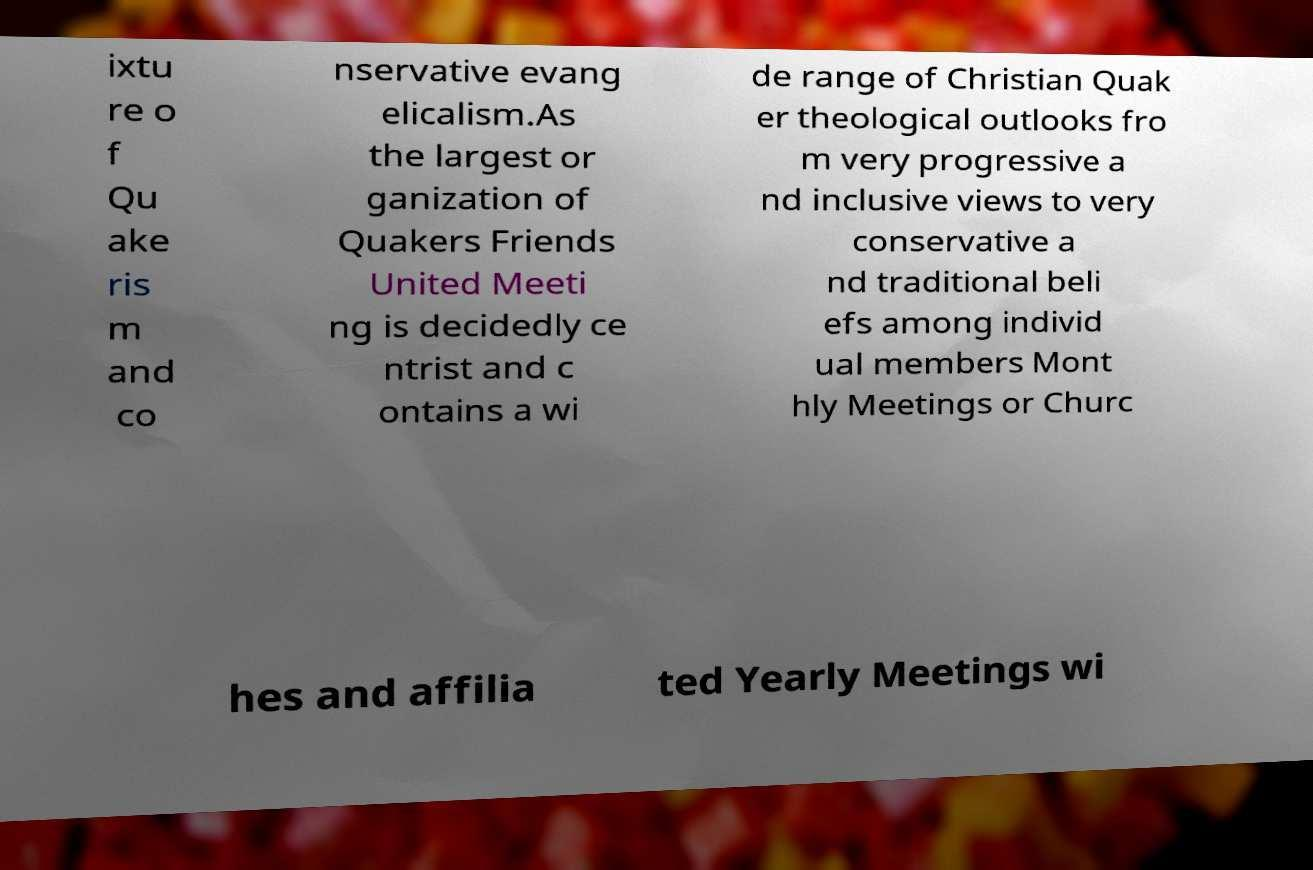Please identify and transcribe the text found in this image. ixtu re o f Qu ake ris m and co nservative evang elicalism.As the largest or ganization of Quakers Friends United Meeti ng is decidedly ce ntrist and c ontains a wi de range of Christian Quak er theological outlooks fro m very progressive a nd inclusive views to very conservative a nd traditional beli efs among individ ual members Mont hly Meetings or Churc hes and affilia ted Yearly Meetings wi 